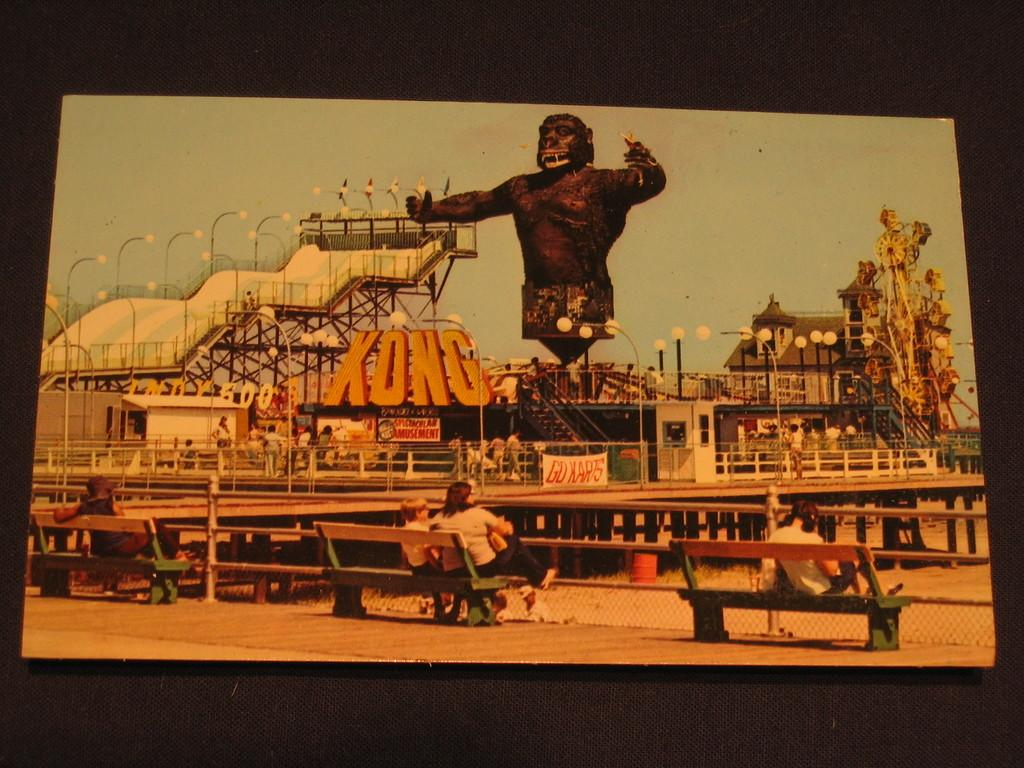<image>
Share a concise interpretation of the image provided. A picture of a theme park with King Kong and the word "Kong." 